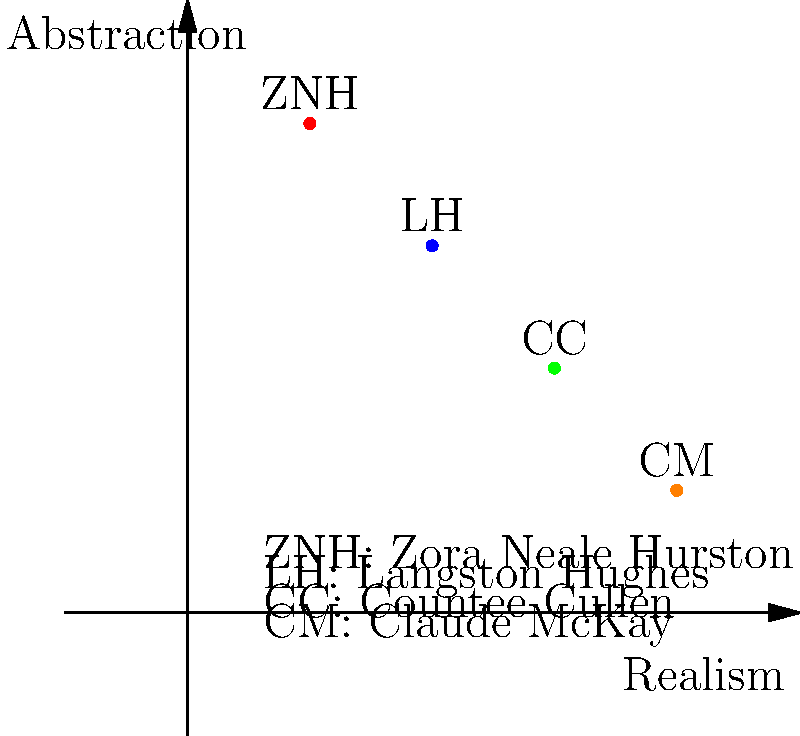Based on the graph comparing artistic styles of Harlem Renaissance figures, which author's portrait style is depicted as the most realistic according to the axes? To answer this question, we need to analyze the graph and understand its axes:

1. The x-axis represents the spectrum from abstraction (left) to realism (right).
2. The y-axis represents the level of abstraction, with higher values indicating more abstraction.

Now, let's examine the positions of each author:

1. Zora Neale Hurston (ZNH): (1,4)
2. Langston Hughes (LH): (2,3)
3. Countee Cullen (CC): (3,2)
4. Claude McKay (CM): (4,1)

The author whose portrait style is depicted as the most realistic would be the one furthest to the right on the x-axis and lowest on the y-axis. This combination indicates the highest level of realism and the lowest level of abstraction.

Looking at the coordinates, we can see that Claude McKay (CM) is positioned at (4,1), which is the furthest right and lowest point among all the authors represented.

Therefore, according to this graph, Claude McKay's portrait style is depicted as the most realistic among the Harlem Renaissance figures shown.
Answer: Claude McKay 